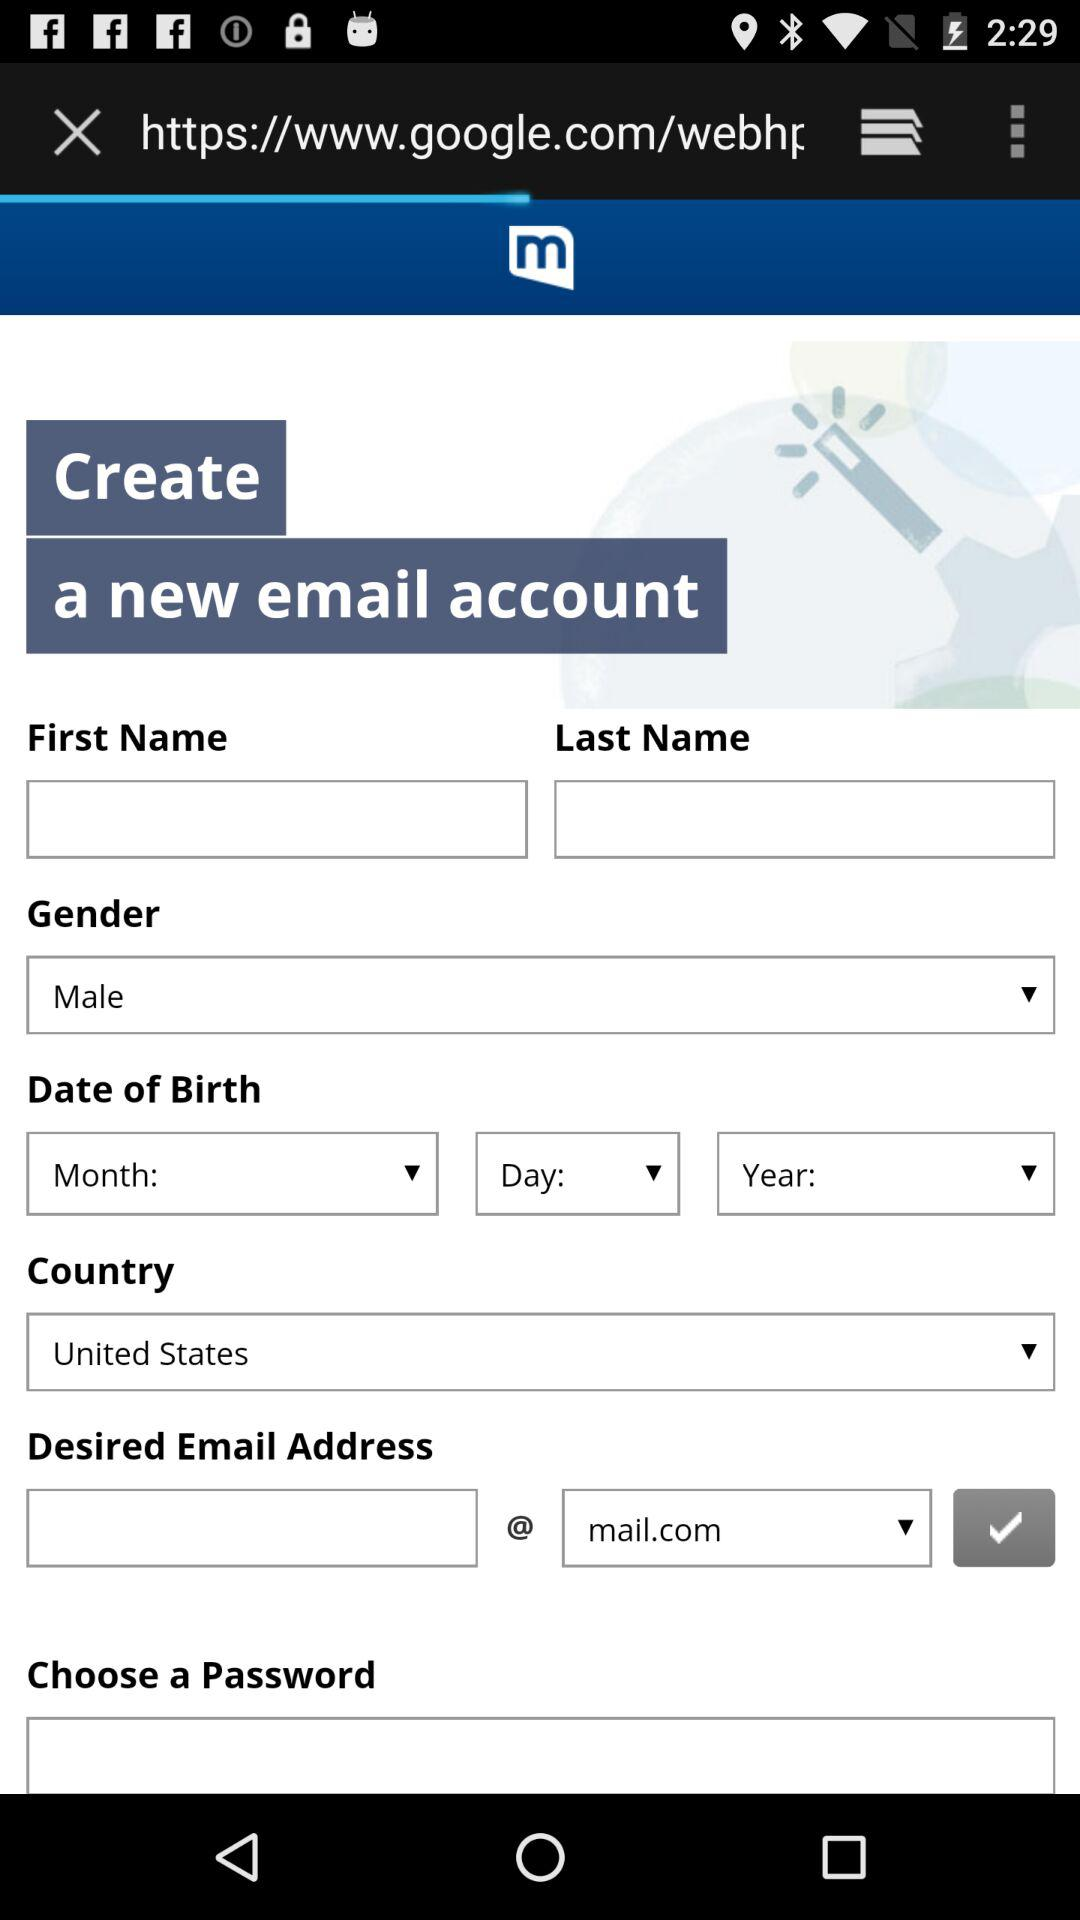What is the country name? The country name is the United States. 